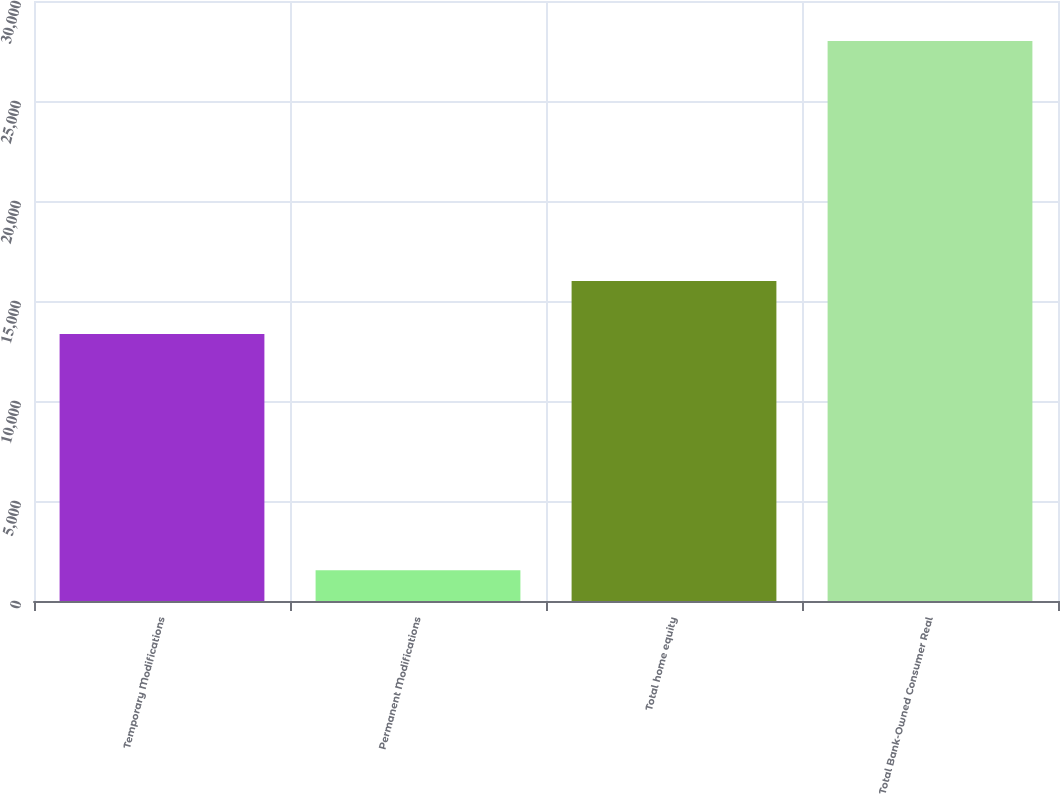Convert chart. <chart><loc_0><loc_0><loc_500><loc_500><bar_chart><fcel>Temporary Modifications<fcel>Permanent Modifications<fcel>Total home equity<fcel>Total Bank-Owned Consumer Real<nl><fcel>13352<fcel>1533<fcel>15998.2<fcel>27995<nl></chart> 